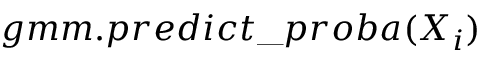<formula> <loc_0><loc_0><loc_500><loc_500>g m m . p r e d i c t \_ p r o b a ( X _ { i } )</formula> 